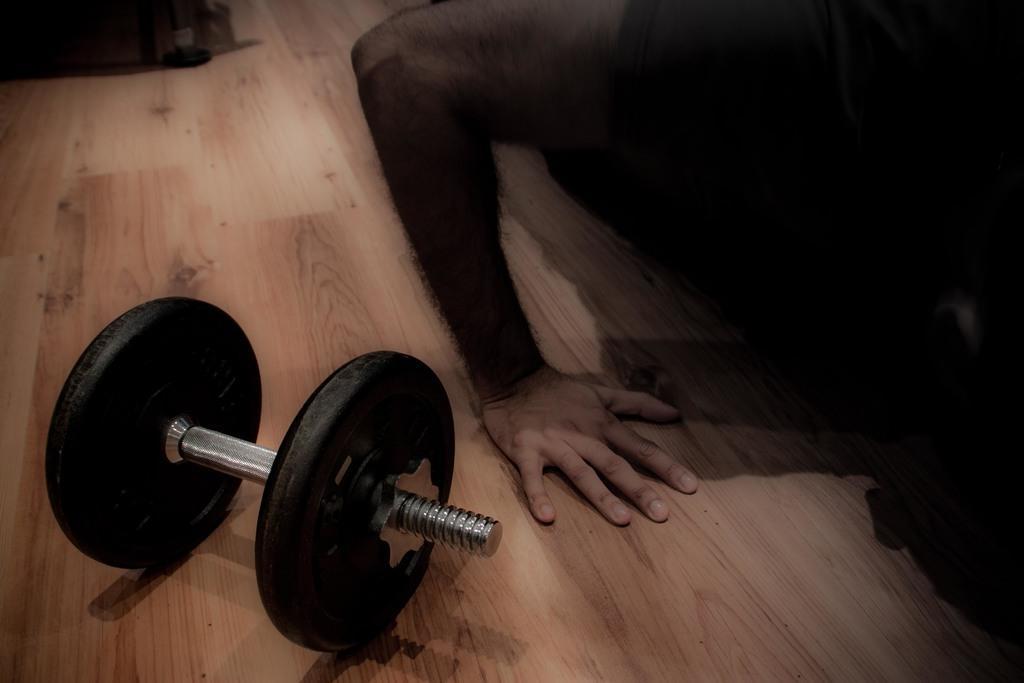Describe this image in one or two sentences. In this image I can see the gym equipment and I can also see the person and the floor is in brown color. 